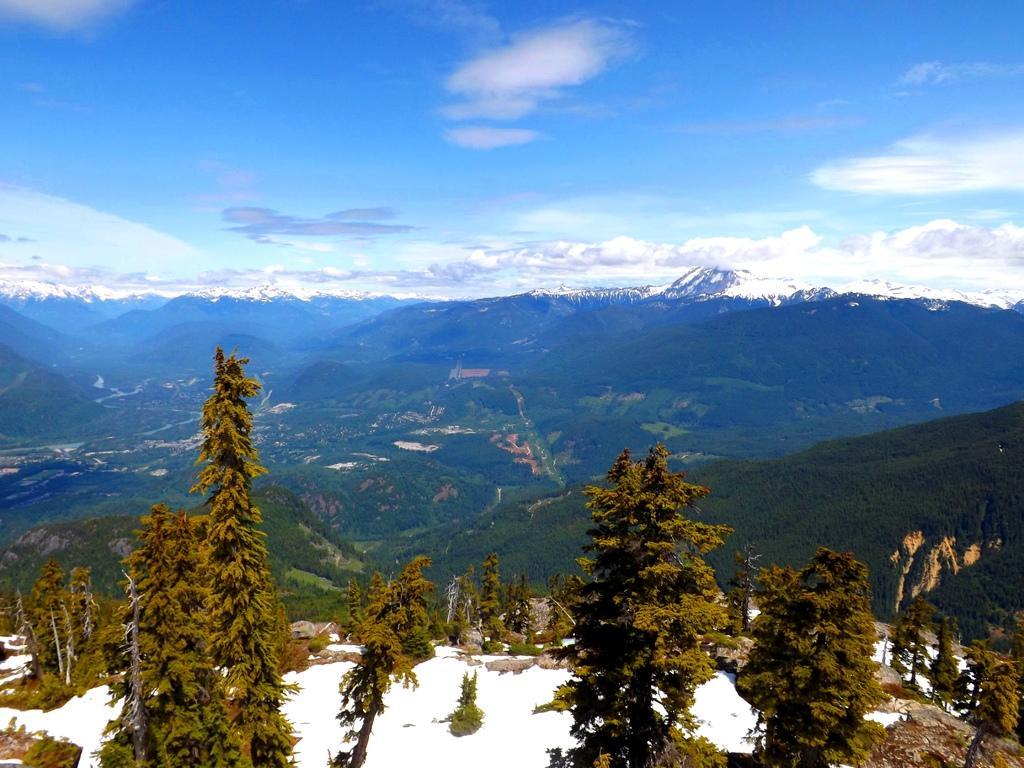Could you give a brief overview of what you see in this image? In this image at the bottom there is some snow and trees, and in the background there are some mountains, trees and the top of the image there is sky. 